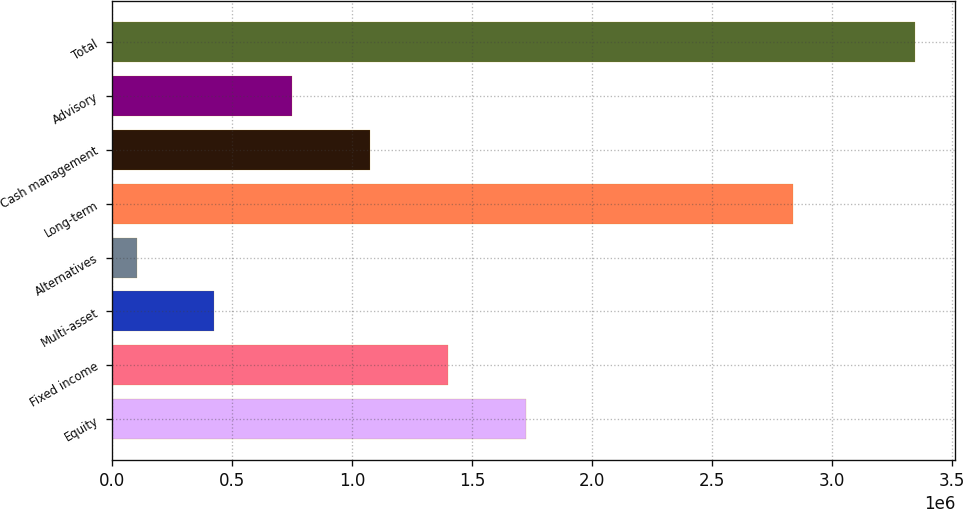<chart> <loc_0><loc_0><loc_500><loc_500><bar_chart><fcel>Equity<fcel>Fixed income<fcel>Multi-asset<fcel>Alternatives<fcel>Long-term<fcel>Cash management<fcel>Advisory<fcel>Total<nl><fcel>1.72418e+06<fcel>1.39976e+06<fcel>426516<fcel>102101<fcel>2.83581e+06<fcel>1.07535e+06<fcel>750932<fcel>3.34626e+06<nl></chart> 